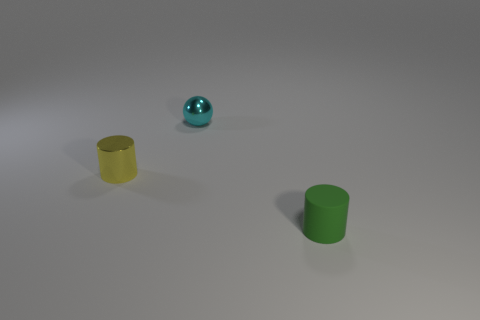Are there any other things that have the same size as the yellow cylinder?
Provide a succinct answer. Yes. Is the number of tiny yellow objects behind the yellow object greater than the number of yellow things that are right of the small ball?
Provide a short and direct response. No. Do the shiny cylinder and the cyan thing have the same size?
Make the answer very short. Yes. The small cylinder that is left of the green object that is in front of the small yellow cylinder is what color?
Keep it short and to the point. Yellow. What is the color of the small shiny cylinder?
Ensure brevity in your answer.  Yellow. Are there any matte objects that have the same color as the small rubber cylinder?
Offer a very short reply. No. Do the object on the right side of the shiny ball and the ball have the same color?
Offer a terse response. No. How many objects are either tiny shiny objects that are on the left side of the cyan object or green rubber objects?
Ensure brevity in your answer.  2. Are there any yellow metal cylinders in front of the green object?
Make the answer very short. No. Do the small object behind the tiny yellow metallic cylinder and the green thing have the same material?
Your answer should be very brief. No. 